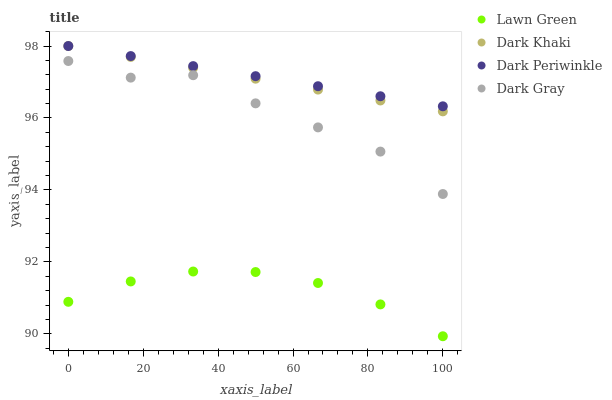Does Lawn Green have the minimum area under the curve?
Answer yes or no. Yes. Does Dark Periwinkle have the maximum area under the curve?
Answer yes or no. Yes. Does Dark Gray have the minimum area under the curve?
Answer yes or no. No. Does Dark Gray have the maximum area under the curve?
Answer yes or no. No. Is Dark Khaki the smoothest?
Answer yes or no. Yes. Is Dark Gray the roughest?
Answer yes or no. Yes. Is Lawn Green the smoothest?
Answer yes or no. No. Is Lawn Green the roughest?
Answer yes or no. No. Does Lawn Green have the lowest value?
Answer yes or no. Yes. Does Dark Gray have the lowest value?
Answer yes or no. No. Does Dark Periwinkle have the highest value?
Answer yes or no. Yes. Does Dark Gray have the highest value?
Answer yes or no. No. Is Lawn Green less than Dark Khaki?
Answer yes or no. Yes. Is Dark Periwinkle greater than Lawn Green?
Answer yes or no. Yes. Does Dark Khaki intersect Dark Periwinkle?
Answer yes or no. Yes. Is Dark Khaki less than Dark Periwinkle?
Answer yes or no. No. Is Dark Khaki greater than Dark Periwinkle?
Answer yes or no. No. Does Lawn Green intersect Dark Khaki?
Answer yes or no. No. 